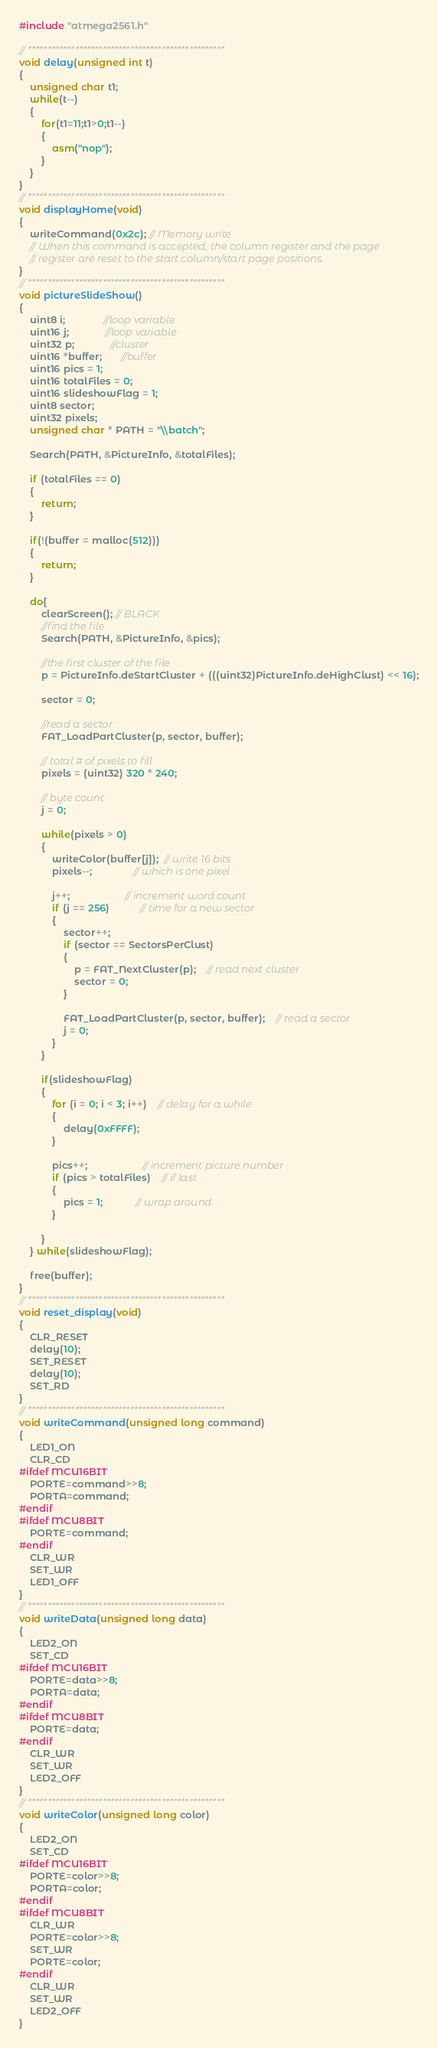<code> <loc_0><loc_0><loc_500><loc_500><_C_>#include "atmega2561.h"

// **************************************************
void delay(unsigned int t)
{
	unsigned char t1;
	while(t--)
	{
		for(t1=11;t1>0;t1--)
		{
			asm("nop");
		}
	}
}
// **************************************************
void displayHome(void)
{
	writeCommand(0x2c); // Memory write
	// When this command is accepted, the column register and the page
	// register are reset to the start column/start page positions.
}
// **************************************************
void pictureSlideShow()
{
	uint8 i;              //loop variable
	uint16 j;             //loop variable
	uint32 p;             //cluster
	uint16 *buffer;       //buffer
	uint16 pics = 1;
	uint16 totalFiles = 0;
	uint16 slideshowFlag = 1;
	uint8 sector;
	uint32 pixels;
	unsigned char * PATH = "\\batch";

	Search(PATH, &PictureInfo, &totalFiles);

	if (totalFiles == 0)
	{
		return;
	}

	if(!(buffer = malloc(512)))
	{
		return;
	}
	
	do{
		clearScreen(); // BLACK
		//find the file
		Search(PATH, &PictureInfo, &pics);
		
		//the first cluster of the file
		p = PictureInfo.deStartCluster + (((uint32)PictureInfo.deHighClust) << 16);
		
		sector = 0;

		//read a sector
		FAT_LoadPartCluster(p, sector, buffer);

		// total # of pixels to fill
		pixels = (uint32) 320 * 240;

		// byte count
		j = 0; 
	
		while(pixels > 0)
		{
			writeColor(buffer[j]);  // write 16 bits
			pixels--;               // which is one pixel
			
			j++;                    // increment word count
			if (j == 256)           // time for a new sector
			{
				sector++;
				if (sector == SectorsPerClust)
				{
					p = FAT_NextCluster(p);	// read next cluster
					sector = 0;
				}

				FAT_LoadPartCluster(p, sector, buffer);	// read a sector
				j = 0;
			}
		}

		if(slideshowFlag)
		{
			for (i = 0; i < 3; i++)	// delay for a while
			{
				delay(0xFFFF);
			}

			pics++;					// increment picture number
			if (pics > totalFiles)	// if last
			{
				pics = 1;			// wrap around
			}

		}
	} while(slideshowFlag);
	
	free(buffer);
}
// **************************************************
void reset_display(void)
{
	CLR_RESET
	delay(10);
	SET_RESET
	delay(10);
	SET_RD
}
// **************************************************
void writeCommand(unsigned long command)
{
	LED1_ON
	CLR_CD
#ifdef MCU16BIT
	PORTE=command>>8;
	PORTA=command;
#endif
#ifdef MCU8BIT
	PORTE=command;
#endif
	CLR_WR
	SET_WR
	LED1_OFF
}
// **************************************************
void writeData(unsigned long data)
{
	LED2_ON
	SET_CD
#ifdef MCU16BIT
	PORTE=data>>8;
	PORTA=data;
#endif
#ifdef MCU8BIT
	PORTE=data;
#endif
	CLR_WR
	SET_WR
	LED2_OFF
}
// **************************************************
void writeColor(unsigned long color)
{
	LED2_ON
	SET_CD
#ifdef MCU16BIT	
	PORTE=color>>8;
	PORTA=color;
#endif
#ifdef MCU8BIT
 	CLR_WR
 	PORTE=color>>8;
 	SET_WR
	PORTE=color;
#endif
	CLR_WR
	SET_WR
	LED2_OFF
}
</code> 